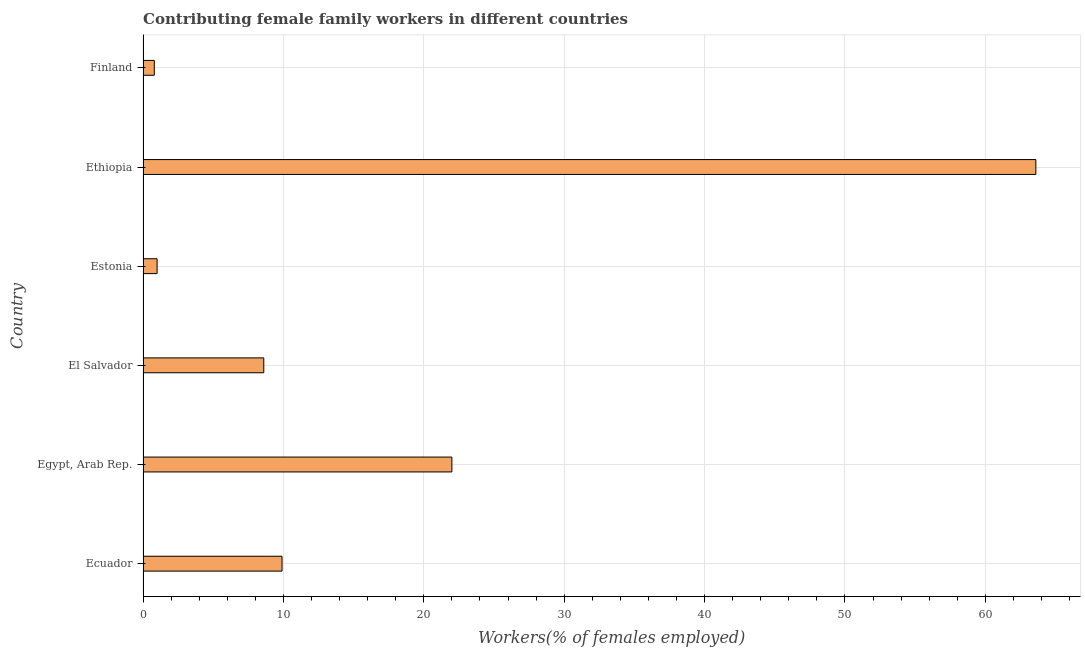Does the graph contain grids?
Your answer should be compact. Yes. What is the title of the graph?
Offer a terse response. Contributing female family workers in different countries. What is the label or title of the X-axis?
Your answer should be very brief. Workers(% of females employed). What is the contributing female family workers in Estonia?
Give a very brief answer. 1. Across all countries, what is the maximum contributing female family workers?
Offer a very short reply. 63.6. Across all countries, what is the minimum contributing female family workers?
Your response must be concise. 0.8. In which country was the contributing female family workers maximum?
Your response must be concise. Ethiopia. In which country was the contributing female family workers minimum?
Make the answer very short. Finland. What is the sum of the contributing female family workers?
Give a very brief answer. 105.9. What is the average contributing female family workers per country?
Keep it short and to the point. 17.65. What is the median contributing female family workers?
Ensure brevity in your answer.  9.25. What is the ratio of the contributing female family workers in Ethiopia to that in Finland?
Your response must be concise. 79.5. Is the contributing female family workers in Egypt, Arab Rep. less than that in El Salvador?
Provide a short and direct response. No. Is the difference between the contributing female family workers in Ecuador and Finland greater than the difference between any two countries?
Your answer should be very brief. No. What is the difference between the highest and the second highest contributing female family workers?
Offer a terse response. 41.6. Is the sum of the contributing female family workers in Ecuador and El Salvador greater than the maximum contributing female family workers across all countries?
Offer a terse response. No. What is the difference between the highest and the lowest contributing female family workers?
Keep it short and to the point. 62.8. In how many countries, is the contributing female family workers greater than the average contributing female family workers taken over all countries?
Your answer should be compact. 2. How many bars are there?
Offer a very short reply. 6. Are all the bars in the graph horizontal?
Provide a succinct answer. Yes. How many countries are there in the graph?
Offer a terse response. 6. Are the values on the major ticks of X-axis written in scientific E-notation?
Provide a succinct answer. No. What is the Workers(% of females employed) of Ecuador?
Ensure brevity in your answer.  9.9. What is the Workers(% of females employed) of Egypt, Arab Rep.?
Provide a succinct answer. 22. What is the Workers(% of females employed) in El Salvador?
Your answer should be very brief. 8.6. What is the Workers(% of females employed) in Ethiopia?
Offer a terse response. 63.6. What is the Workers(% of females employed) in Finland?
Your answer should be very brief. 0.8. What is the difference between the Workers(% of females employed) in Ecuador and Estonia?
Offer a terse response. 8.9. What is the difference between the Workers(% of females employed) in Ecuador and Ethiopia?
Offer a very short reply. -53.7. What is the difference between the Workers(% of females employed) in Egypt, Arab Rep. and Ethiopia?
Your answer should be compact. -41.6. What is the difference between the Workers(% of females employed) in Egypt, Arab Rep. and Finland?
Your answer should be very brief. 21.2. What is the difference between the Workers(% of females employed) in El Salvador and Estonia?
Make the answer very short. 7.6. What is the difference between the Workers(% of females employed) in El Salvador and Ethiopia?
Your answer should be compact. -55. What is the difference between the Workers(% of females employed) in El Salvador and Finland?
Your answer should be compact. 7.8. What is the difference between the Workers(% of females employed) in Estonia and Ethiopia?
Give a very brief answer. -62.6. What is the difference between the Workers(% of females employed) in Estonia and Finland?
Give a very brief answer. 0.2. What is the difference between the Workers(% of females employed) in Ethiopia and Finland?
Provide a short and direct response. 62.8. What is the ratio of the Workers(% of females employed) in Ecuador to that in Egypt, Arab Rep.?
Keep it short and to the point. 0.45. What is the ratio of the Workers(% of females employed) in Ecuador to that in El Salvador?
Keep it short and to the point. 1.15. What is the ratio of the Workers(% of females employed) in Ecuador to that in Ethiopia?
Make the answer very short. 0.16. What is the ratio of the Workers(% of females employed) in Ecuador to that in Finland?
Offer a terse response. 12.38. What is the ratio of the Workers(% of females employed) in Egypt, Arab Rep. to that in El Salvador?
Offer a very short reply. 2.56. What is the ratio of the Workers(% of females employed) in Egypt, Arab Rep. to that in Estonia?
Your answer should be very brief. 22. What is the ratio of the Workers(% of females employed) in Egypt, Arab Rep. to that in Ethiopia?
Your response must be concise. 0.35. What is the ratio of the Workers(% of females employed) in El Salvador to that in Ethiopia?
Provide a short and direct response. 0.14. What is the ratio of the Workers(% of females employed) in El Salvador to that in Finland?
Give a very brief answer. 10.75. What is the ratio of the Workers(% of females employed) in Estonia to that in Ethiopia?
Ensure brevity in your answer.  0.02. What is the ratio of the Workers(% of females employed) in Ethiopia to that in Finland?
Keep it short and to the point. 79.5. 